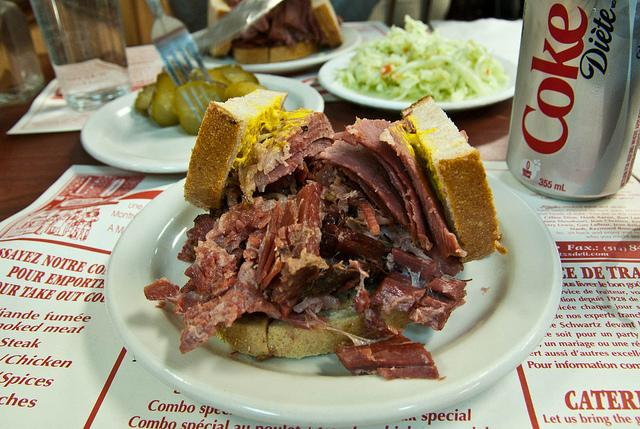What type of sandwich is this? Please explain your reasoning. corned beef. The sandwich is made from thickly sliced pinkish meat. 